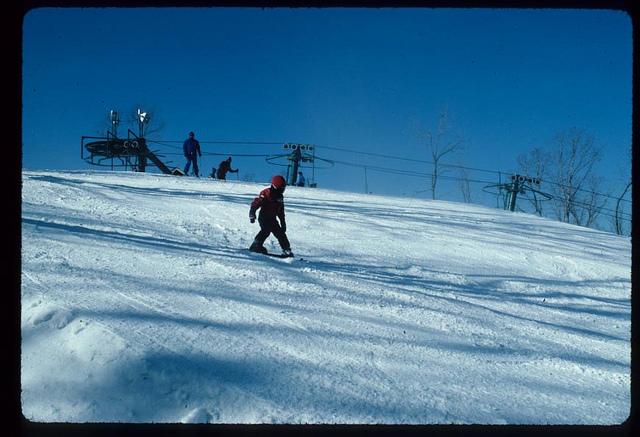Are there mountains in the distance?
Write a very short answer. No. What color is the person's hat?
Write a very short answer. Red. Does the boarder wear head protection?
Short answer required. Yes. What is the machine in the background called?
Quick response, please. Ski lift. Who has their skis crossed?
Concise answer only. Skier. Is this a recent photo?
Be succinct. Yes. Is the man skiing or snowboarding?
Be succinct. Snowboarding. Is the snow deep?
Give a very brief answer. Yes. 